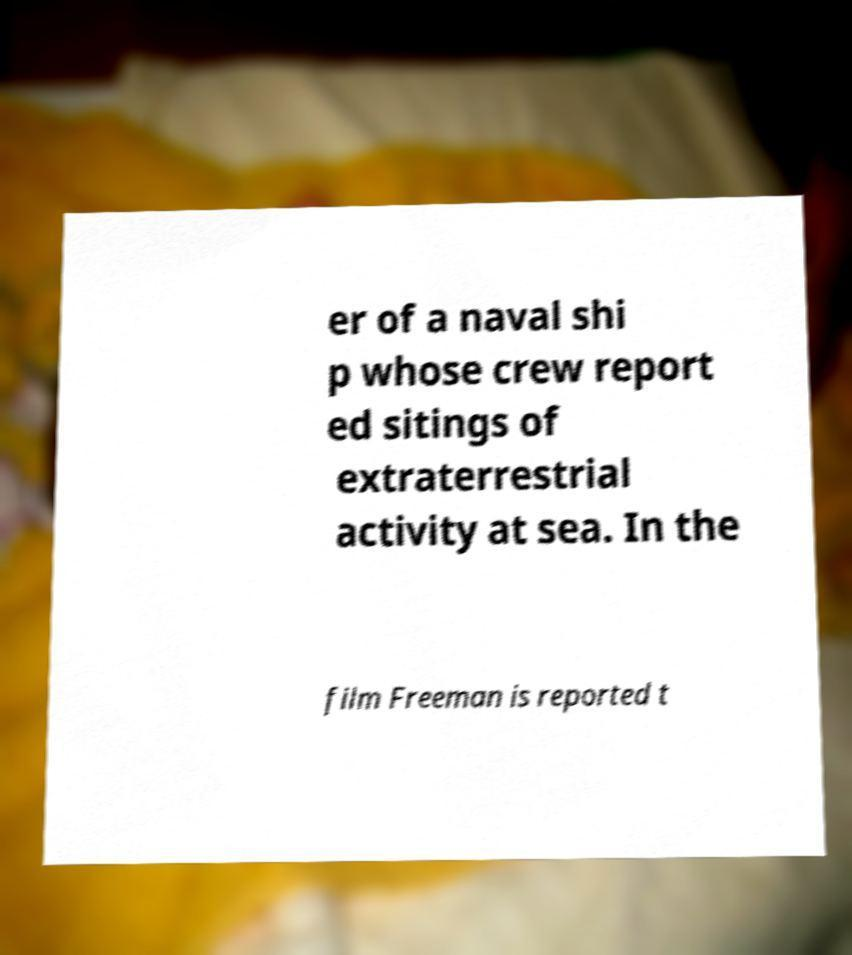Can you accurately transcribe the text from the provided image for me? er of a naval shi p whose crew report ed sitings of extraterrestrial activity at sea. In the film Freeman is reported t 